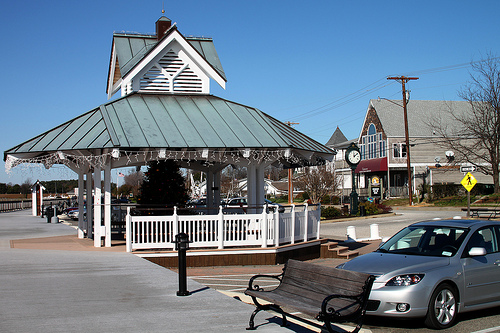Imagine a seasonal event happening in this image. Describe it. The image could be set during a festive winter event. Picture the gazebo adorned with sparkling holiday lights and garlands. Snow blankets the rooftops and ground, adding a magical touch. People gather around, sipping hot cocoa, and there's a small group of carolers singing festive tunes near the gazebo. The atmosphere is filled with the joyous sounds and sights of a holiday market, complete with vendors selling handmade crafts and baked goods. What other types of shops or activities might you expect to see in this area? Given the quaint and picturesque setting, one might expect to see a variety of charming shops and activities. There could be a local bakery known for its warm pastries and fresh bread, a small bookstore with cozy reading nooks, and an art gallery featuring works by local artists. You might also find a farmer's market offering fresh produce and homemade jams on weekends, and perhaps a small café where people gather for coffee and conversation. 